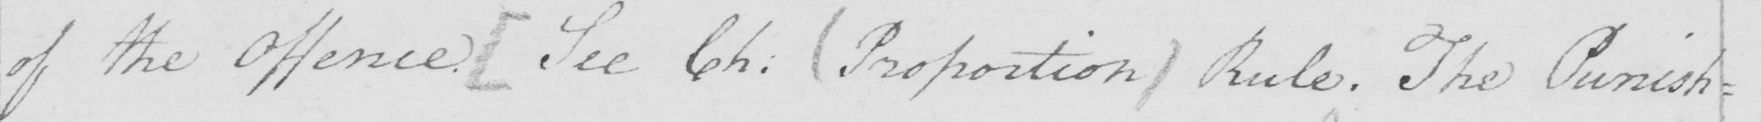Can you tell me what this handwritten text says? of the Offence .  [ See Ch :   ( Proposition )  Rule . the Punish= 